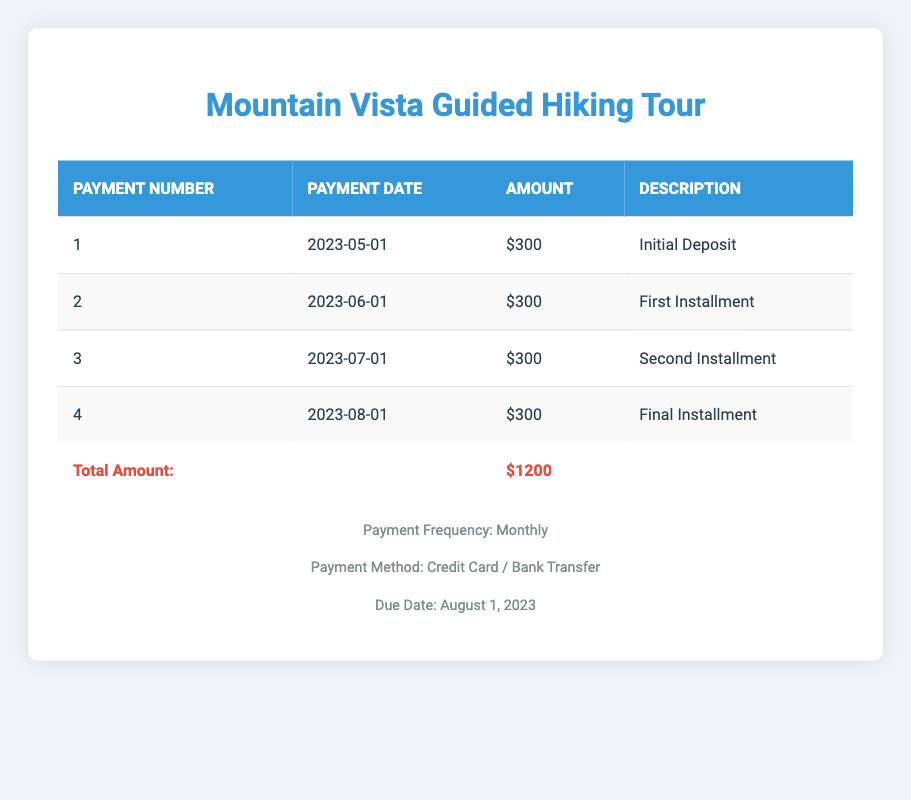What is the total price of the Mountain Vista Guided Hiking Tour? The total price is listed in the table, under the "Total Amount" section, which clearly states the total at the bottom of the table.
Answer: 1200 When is the due date for the final payment? The due date is provided in the footer section of the table, specifically indicating when the complete amount is due.
Answer: August 1, 2023 How many payments are included in the payment plan? The payment plan consists of four installments, as detailed in the rows of the table. The rows are numbered 1 through 4, indicating each payment.
Answer: 4 What is the amount for each installment? Each installment amount is consistently listed as 300 in the table for all payment entries, confirming that there is no variation in the installment amounts.
Answer: 300 What is the total amount paid by the due date? The total amount paid by the due date is again indicated at the bottom of the table. Since there are four payments of 300 each, the total equals 1200.
Answer: 1200 Is the initial deposit the same as the first installment? Checking the amounts in the table, the initial deposit is 300, which matches the first installment amount; hence, the statement is true.
Answer: Yes How many months apart are the payments? The payments are scheduled once a month, as shown in the payment dates. Each installment listed in the table occurs one month after the previous one.
Answer: 1 month What is the payment method accepted for this tour package? The payment method is described in the footer, stating that the payments can be made via Credit Card or Bank Transfer.
Answer: Credit Card / Bank Transfer If a traveler starts to pay from June 1, how many payments are left after that date? Starting from June 1, the first payment is made, leaving three remaining payments (June, July, August) as per the payment plan outlined in the table.
Answer: 3 